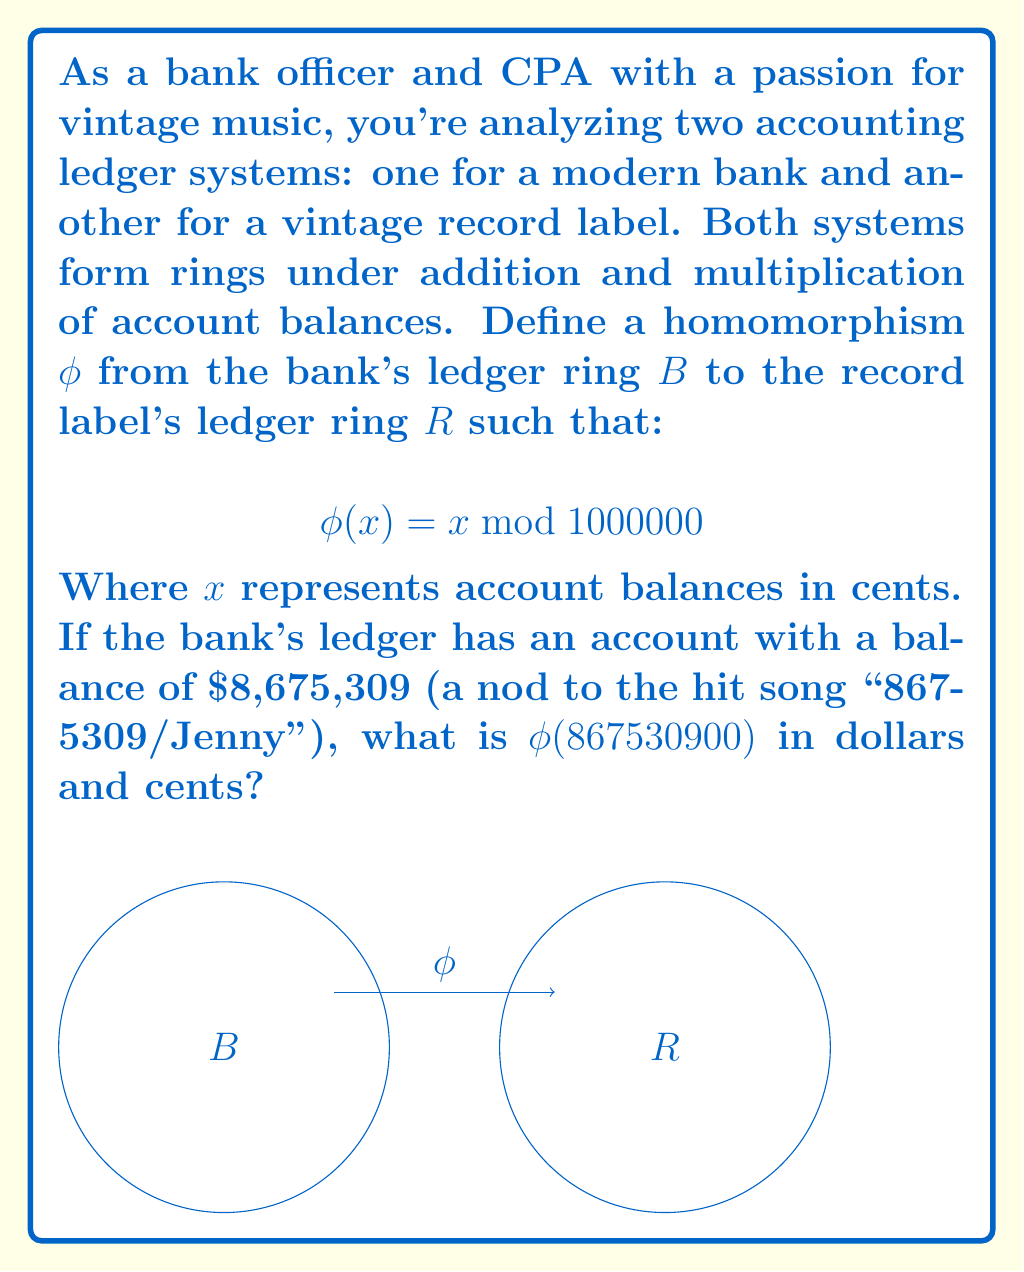Show me your answer to this math problem. Let's approach this step-by-step:

1) First, we need to understand what the homomorphism $\phi$ does:
   It takes an account balance from the bank's ledger and maps it to the remainder when divided by 1,000,000 cents ($\$10,000$).

2) The given balance is $\$8,675,309$. We need to convert this to cents:
   $$8,675,309 \times 100 = 867,530,900 \text{ cents}$$

3) Now, we apply the homomorphism:
   $$\phi(867530900) = 867530900 \mod 1000000$$

4) To calculate this, we divide 867,530,900 by 1,000,000 and take the remainder:
   $$867530900 \div 1000000 = 867 \text{ remainder } 530900$$

5) Therefore, $\phi(867530900) = 530900$ cents

6) To convert this back to dollars and cents, we divide by 100:
   $$530900 \div 100 = 5309.00$$

Thus, $\phi(867530900) = \$5,309.00$
Answer: $\$5,309.00$ 